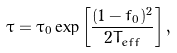Convert formula to latex. <formula><loc_0><loc_0><loc_500><loc_500>\tau = \tau _ { 0 } \exp \left [ \frac { ( 1 - f _ { 0 } ) ^ { 2 } } { 2 T _ { e f f } } \right ] ,</formula> 